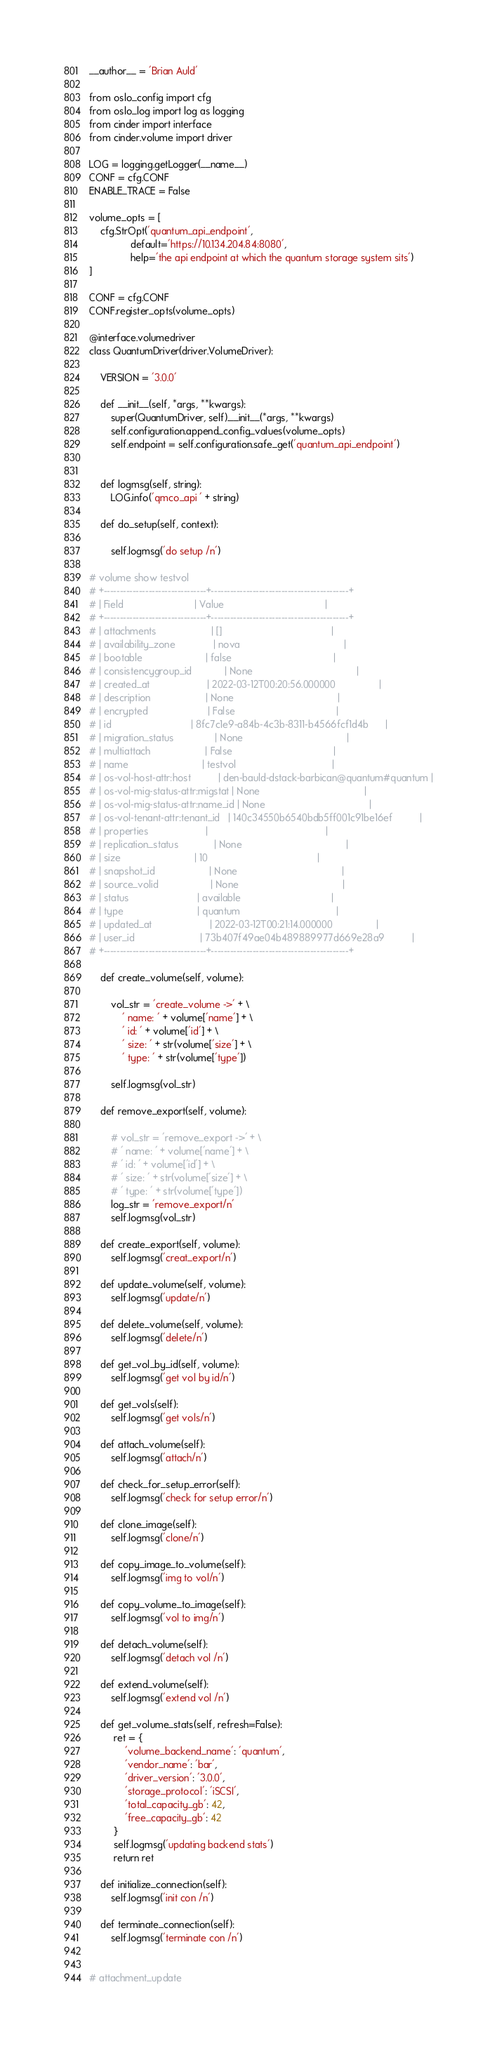<code> <loc_0><loc_0><loc_500><loc_500><_Python_>__author__ = 'Brian Auld'

from oslo_config import cfg
from oslo_log import log as logging
from cinder import interface
from cinder.volume import driver

LOG = logging.getLogger(__name__)
CONF = cfg.CONF
ENABLE_TRACE = False

volume_opts = [
    cfg.StrOpt('quantum_api_endpoint',
               default='https://10.134.204.84:8080',
               help='the api endpoint at which the quantum storage system sits')
]

CONF = cfg.CONF
CONF.register_opts(volume_opts)

@interface.volumedriver
class QuantumDriver(driver.VolumeDriver):

    VERSION = '3.0.0'

    def __init__(self, *args, **kwargs):
        super(QuantumDriver, self).__init__(*args, **kwargs)
        self.configuration.append_config_values(volume_opts)
        self.endpoint = self.configuration.safe_get('quantum_api_endpoint')


    def logmsg(self, string):
        LOG.info('qmco_api ' + string)

    def do_setup(self, context):
        
        self.logmsg('do setup /n')

# volume show testvol
# +--------------------------------+-------------------------------------------+
# | Field                          | Value                                     |
# +--------------------------------+-------------------------------------------+
# | attachments                    | []                                        |
# | availability_zone              | nova                                      |
# | bootable                       | false                                     |
# | consistencygroup_id            | None                                      |
# | created_at                     | 2022-03-12T00:20:56.000000                |
# | description                    | None                                      |
# | encrypted                      | False                                     |
# | id                             | 8fc7c1e9-a84b-4c3b-8311-b4566fcf1d4b      |
# | migration_status               | None                                      |
# | multiattach                    | False                                     |
# | name                           | testvol                                   |
# | os-vol-host-attr:host          | den-bauld-dstack-barbican@quantum#quantum |
# | os-vol-mig-status-attr:migstat | None                                      |
# | os-vol-mig-status-attr:name_id | None                                      |
# | os-vol-tenant-attr:tenant_id   | 140c34550b6540bdb5ff001c91be16ef          |
# | properties                     |                                           |
# | replication_status             | None                                      |
# | size                           | 10                                        |
# | snapshot_id                    | None                                      |
# | source_volid                   | None                                      |
# | status                         | available                                 |
# | type                           | quantum                                   |
# | updated_at                     | 2022-03-12T00:21:14.000000                |
# | user_id                        | 73b407f49ae04b489889977d669e28a9          |
# +--------------------------------+-------------------------------------------+

    def create_volume(self, volume):
        
        vol_str = 'create_volume ->' + \
            ' name: ' + volume['name'] + \
            ' id: ' + volume['id'] + \
            ' size: ' + str(volume['size'] + \
            ' type: ' + str(volume['type'])
        
        self.logmsg(vol_str)

    def remove_export(self, volume):

        # vol_str = 'remove_export ->' + \
        # ' name: ' + volume['name'] + \
        # ' id: ' + volume['id'] + \
        # ' size: ' + str(volume['size'] + \
        # ' type: ' + str(volume['type'])
        log_str = 'remove_export/n'
        self.logmsg(vol_str)
        
    def create_export(self, volume):
        self.logmsg('creat_export/n')
        
    def update_volume(self, volume):
        self.logmsg('update/n')

    def delete_volume(self, volume):
        self.logmsg('delete/n')

    def get_vol_by_id(self, volume):
        self.logmsg('get vol by id/n')

    def get_vols(self):
        self.logmsg('get vols/n')

    def attach_volume(self):
        self.logmsg('attach/n')

    def check_for_setup_error(self):
        self.logmsg('check for setup error/n')

    def clone_image(self):
        self.logmsg('clone/n')

    def copy_image_to_volume(self):
        self.logmsg('img to vol/n')

    def copy_volume_to_image(self):
        self.logmsg('vol to img/n')

    def detach_volume(self):
        self.logmsg('detach vol /n')

    def extend_volume(self):
        self.logmsg('extend vol /n')

    def get_volume_stats(self, refresh=False):
         ret = {
             'volume_backend_name': 'quantum',
             'vendor_name': 'bar',
             'driver_version': '3.0.0',
             'storage_protocol': 'iSCSI',
             'total_capacity_gb': 42,
             'free_capacity_gb': 42
         }
         self.logmsg('updating backend stats')
         return ret

    def initialize_connection(self):
        self.logmsg('init con /n')

    def terminate_connection(self):
        self.logmsg('terminate con /n')


# attachment_update        
</code> 